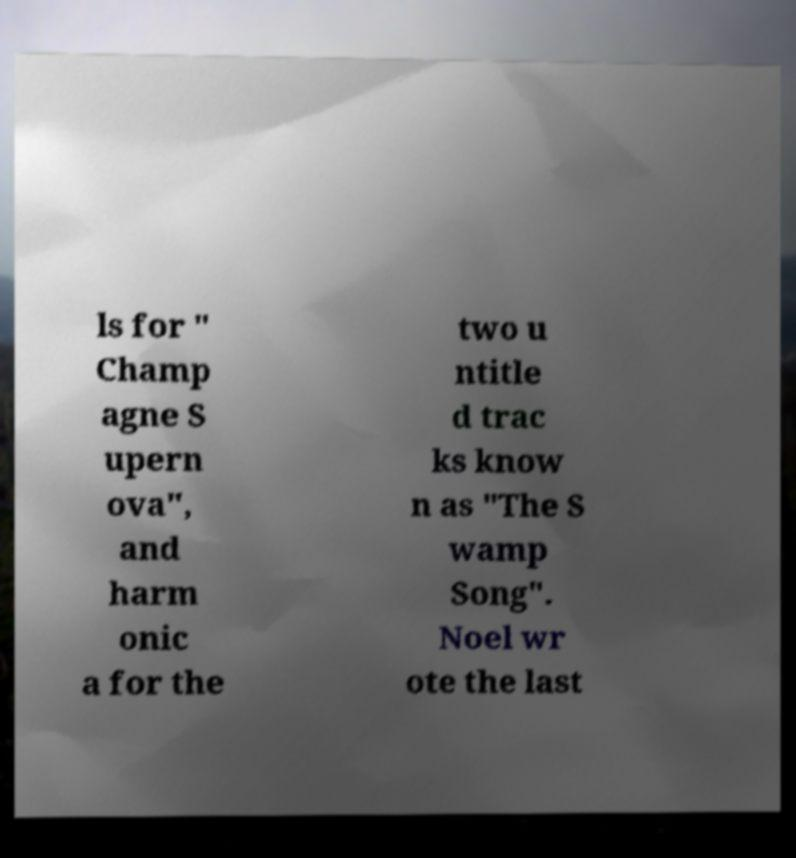I need the written content from this picture converted into text. Can you do that? ls for " Champ agne S upern ova", and harm onic a for the two u ntitle d trac ks know n as "The S wamp Song". Noel wr ote the last 